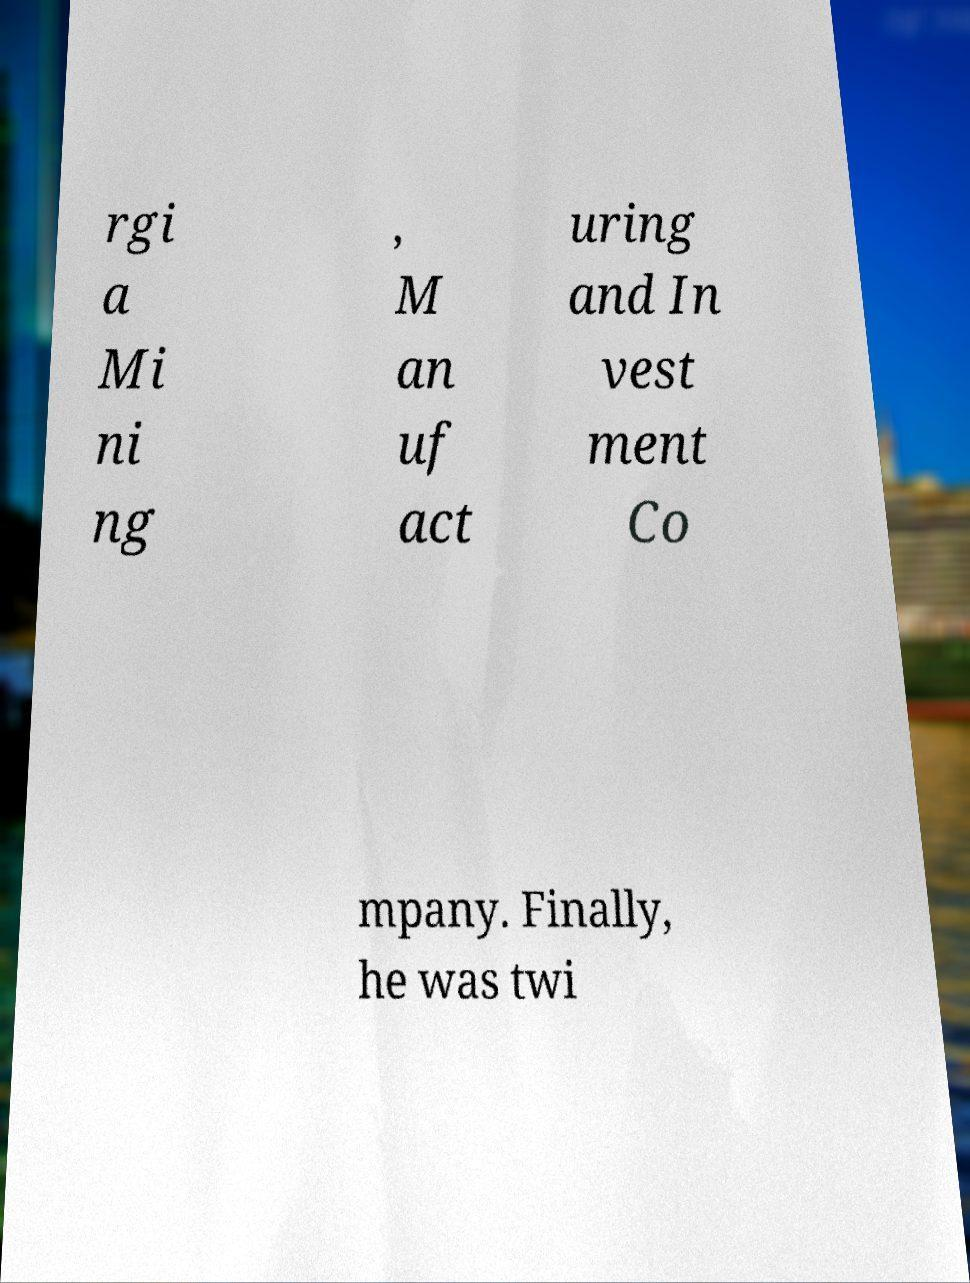I need the written content from this picture converted into text. Can you do that? rgi a Mi ni ng , M an uf act uring and In vest ment Co mpany. Finally, he was twi 